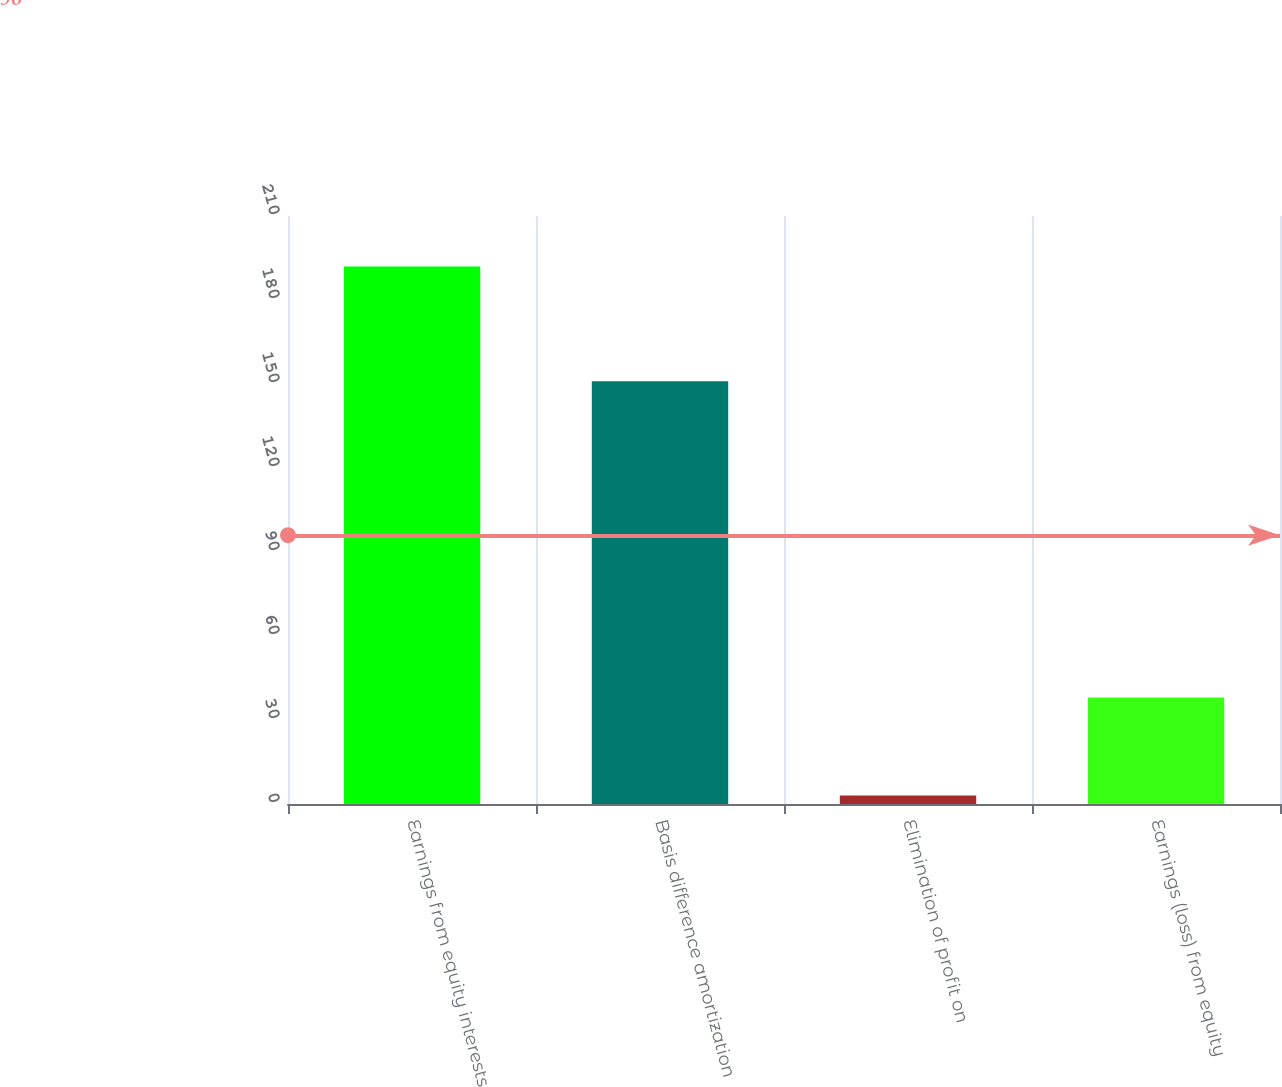Convert chart. <chart><loc_0><loc_0><loc_500><loc_500><bar_chart><fcel>Earnings from equity interests<fcel>Basis difference amortization<fcel>Elimination of profit on<fcel>Earnings (loss) from equity<nl><fcel>192<fcel>151<fcel>3<fcel>38<nl></chart> 